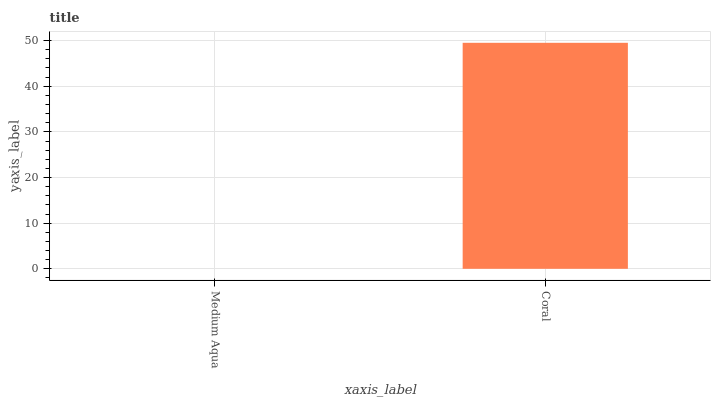Is Medium Aqua the minimum?
Answer yes or no. Yes. Is Coral the maximum?
Answer yes or no. Yes. Is Coral the minimum?
Answer yes or no. No. Is Coral greater than Medium Aqua?
Answer yes or no. Yes. Is Medium Aqua less than Coral?
Answer yes or no. Yes. Is Medium Aqua greater than Coral?
Answer yes or no. No. Is Coral less than Medium Aqua?
Answer yes or no. No. Is Coral the high median?
Answer yes or no. Yes. Is Medium Aqua the low median?
Answer yes or no. Yes. Is Medium Aqua the high median?
Answer yes or no. No. Is Coral the low median?
Answer yes or no. No. 